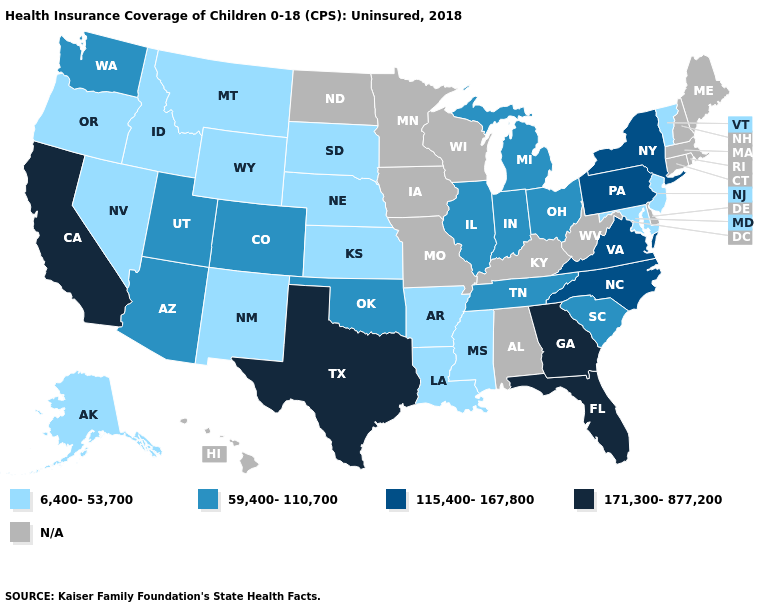Name the states that have a value in the range 115,400-167,800?
Write a very short answer. New York, North Carolina, Pennsylvania, Virginia. What is the value of Alabama?
Answer briefly. N/A. Is the legend a continuous bar?
Give a very brief answer. No. Does the first symbol in the legend represent the smallest category?
Give a very brief answer. Yes. What is the value of North Carolina?
Short answer required. 115,400-167,800. What is the highest value in the USA?
Quick response, please. 171,300-877,200. What is the highest value in states that border Colorado?
Be succinct. 59,400-110,700. What is the lowest value in the USA?
Be succinct. 6,400-53,700. What is the lowest value in the USA?
Write a very short answer. 6,400-53,700. Does Nebraska have the lowest value in the MidWest?
Answer briefly. Yes. Which states hav the highest value in the Northeast?
Write a very short answer. New York, Pennsylvania. How many symbols are there in the legend?
Write a very short answer. 5. How many symbols are there in the legend?
Quick response, please. 5. 